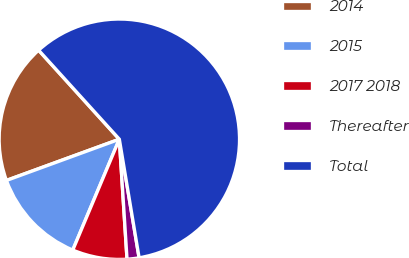<chart> <loc_0><loc_0><loc_500><loc_500><pie_chart><fcel>2014<fcel>2015<fcel>2017 2018<fcel>Thereafter<fcel>Total<nl><fcel>18.85%<fcel>13.1%<fcel>7.35%<fcel>1.61%<fcel>59.09%<nl></chart> 